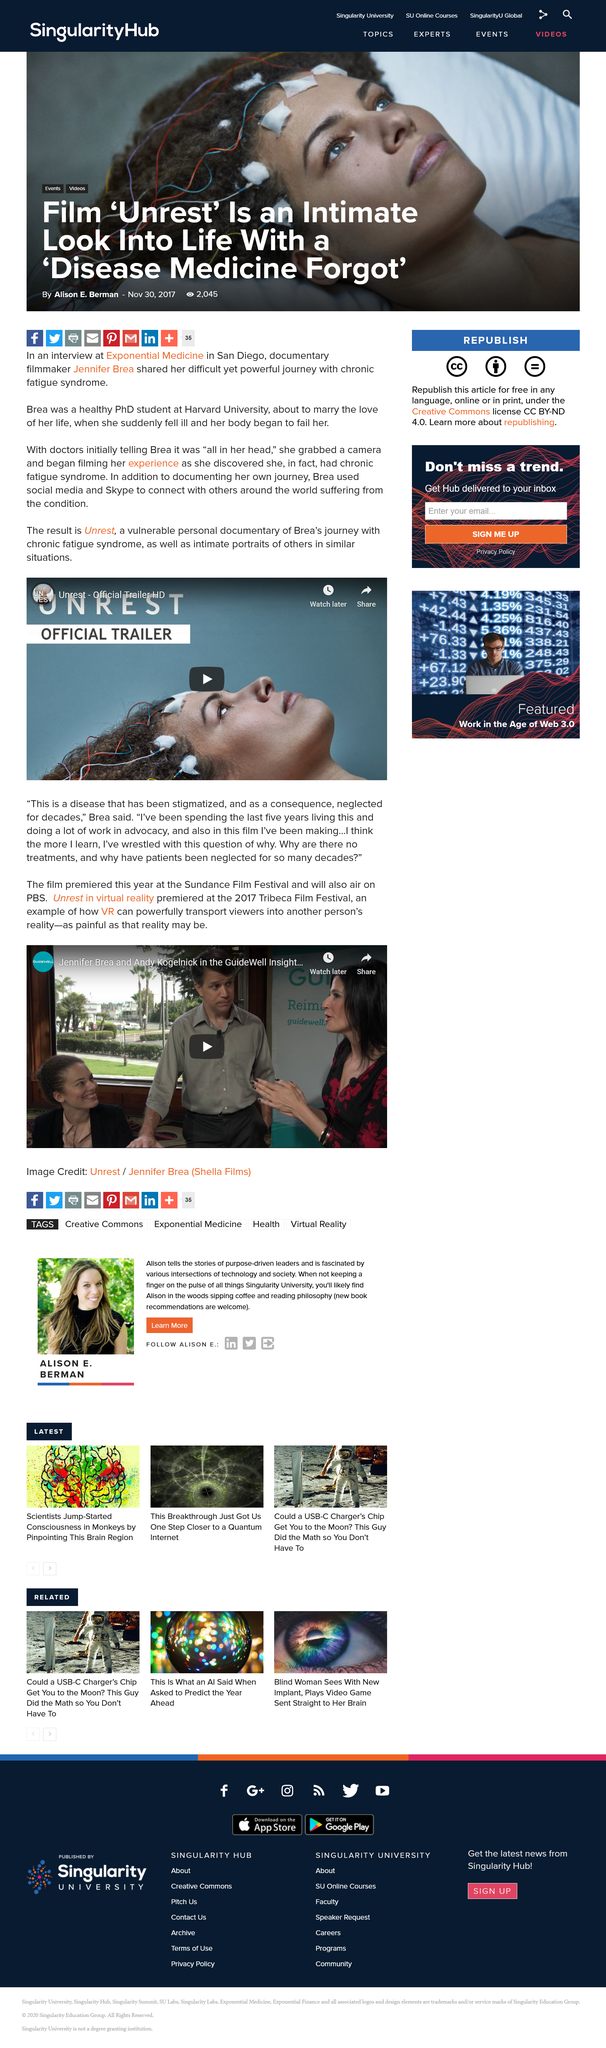Give some essential details in this illustration. Exponential Medicine is located in San Diego. The video is a trailer of a documentary film. Jennifer Brea was a student at Harvard University. 